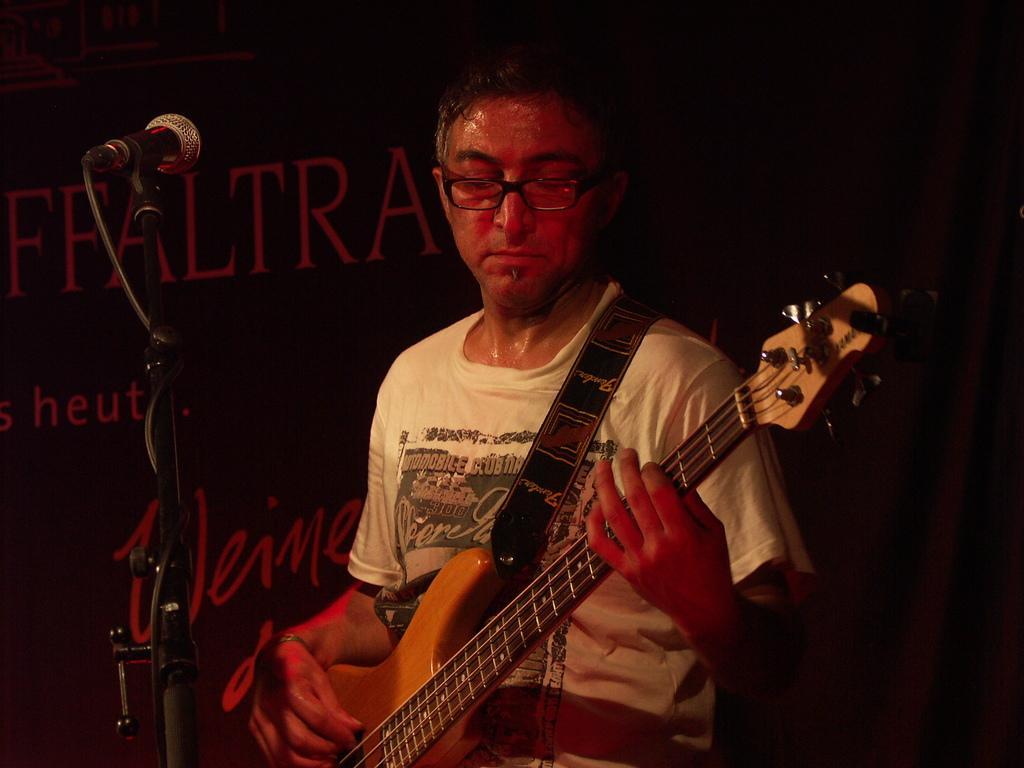Please provide a concise description of this image. In this picture there is man who is playing guitar. he is wearing white t shirt and glasses. In front of him there is mic. In the background there is a banner and curtain. 